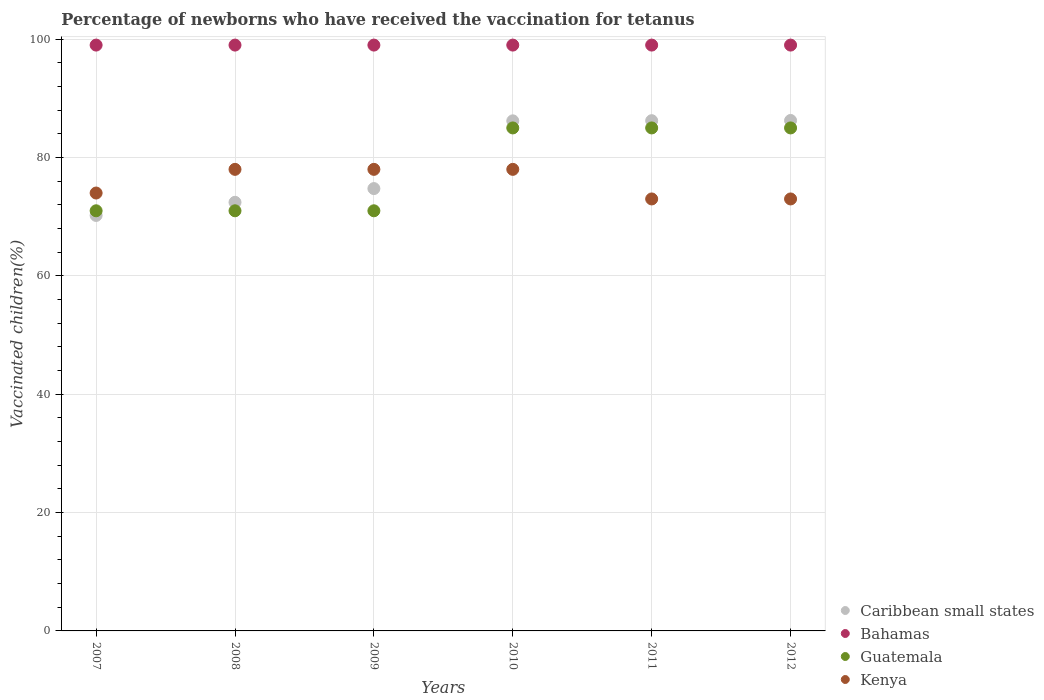How many different coloured dotlines are there?
Provide a short and direct response. 4. What is the percentage of vaccinated children in Caribbean small states in 2011?
Offer a very short reply. 86.23. Across all years, what is the maximum percentage of vaccinated children in Bahamas?
Your answer should be compact. 99. Across all years, what is the minimum percentage of vaccinated children in Kenya?
Make the answer very short. 73. In which year was the percentage of vaccinated children in Guatemala maximum?
Provide a succinct answer. 2010. In which year was the percentage of vaccinated children in Caribbean small states minimum?
Give a very brief answer. 2007. What is the total percentage of vaccinated children in Guatemala in the graph?
Provide a succinct answer. 468. What is the difference between the percentage of vaccinated children in Bahamas in 2011 and the percentage of vaccinated children in Caribbean small states in 2012?
Offer a terse response. 12.74. What is the average percentage of vaccinated children in Kenya per year?
Your answer should be compact. 75.67. In the year 2007, what is the difference between the percentage of vaccinated children in Caribbean small states and percentage of vaccinated children in Bahamas?
Your answer should be compact. -28.79. What is the ratio of the percentage of vaccinated children in Kenya in 2010 to that in 2012?
Your answer should be compact. 1.07. Is the difference between the percentage of vaccinated children in Caribbean small states in 2009 and 2010 greater than the difference between the percentage of vaccinated children in Bahamas in 2009 and 2010?
Your response must be concise. No. What is the difference between the highest and the lowest percentage of vaccinated children in Bahamas?
Offer a terse response. 0. In how many years, is the percentage of vaccinated children in Caribbean small states greater than the average percentage of vaccinated children in Caribbean small states taken over all years?
Ensure brevity in your answer.  3. Is the sum of the percentage of vaccinated children in Guatemala in 2009 and 2012 greater than the maximum percentage of vaccinated children in Bahamas across all years?
Ensure brevity in your answer.  Yes. Is it the case that in every year, the sum of the percentage of vaccinated children in Caribbean small states and percentage of vaccinated children in Kenya  is greater than the sum of percentage of vaccinated children in Guatemala and percentage of vaccinated children in Bahamas?
Provide a succinct answer. No. Is the percentage of vaccinated children in Bahamas strictly less than the percentage of vaccinated children in Kenya over the years?
Your answer should be compact. No. What is the difference between two consecutive major ticks on the Y-axis?
Offer a terse response. 20. Are the values on the major ticks of Y-axis written in scientific E-notation?
Keep it short and to the point. No. Where does the legend appear in the graph?
Offer a very short reply. Bottom right. How are the legend labels stacked?
Your answer should be very brief. Vertical. What is the title of the graph?
Give a very brief answer. Percentage of newborns who have received the vaccination for tetanus. What is the label or title of the X-axis?
Make the answer very short. Years. What is the label or title of the Y-axis?
Your answer should be very brief. Vaccinated children(%). What is the Vaccinated children(%) of Caribbean small states in 2007?
Give a very brief answer. 70.21. What is the Vaccinated children(%) of Bahamas in 2007?
Make the answer very short. 99. What is the Vaccinated children(%) in Guatemala in 2007?
Your response must be concise. 71. What is the Vaccinated children(%) in Caribbean small states in 2008?
Offer a terse response. 72.43. What is the Vaccinated children(%) in Caribbean small states in 2009?
Make the answer very short. 74.75. What is the Vaccinated children(%) in Bahamas in 2009?
Ensure brevity in your answer.  99. What is the Vaccinated children(%) of Caribbean small states in 2010?
Offer a very short reply. 86.2. What is the Vaccinated children(%) in Bahamas in 2010?
Keep it short and to the point. 99. What is the Vaccinated children(%) of Kenya in 2010?
Provide a succinct answer. 78. What is the Vaccinated children(%) in Caribbean small states in 2011?
Your answer should be compact. 86.23. What is the Vaccinated children(%) in Bahamas in 2011?
Make the answer very short. 99. What is the Vaccinated children(%) of Guatemala in 2011?
Keep it short and to the point. 85. What is the Vaccinated children(%) in Caribbean small states in 2012?
Keep it short and to the point. 86.26. What is the Vaccinated children(%) in Kenya in 2012?
Provide a short and direct response. 73. Across all years, what is the maximum Vaccinated children(%) of Caribbean small states?
Make the answer very short. 86.26. Across all years, what is the maximum Vaccinated children(%) in Guatemala?
Ensure brevity in your answer.  85. Across all years, what is the maximum Vaccinated children(%) in Kenya?
Your answer should be very brief. 78. Across all years, what is the minimum Vaccinated children(%) in Caribbean small states?
Provide a short and direct response. 70.21. What is the total Vaccinated children(%) of Caribbean small states in the graph?
Your answer should be compact. 476.08. What is the total Vaccinated children(%) of Bahamas in the graph?
Make the answer very short. 594. What is the total Vaccinated children(%) of Guatemala in the graph?
Give a very brief answer. 468. What is the total Vaccinated children(%) in Kenya in the graph?
Ensure brevity in your answer.  454. What is the difference between the Vaccinated children(%) in Caribbean small states in 2007 and that in 2008?
Make the answer very short. -2.22. What is the difference between the Vaccinated children(%) of Bahamas in 2007 and that in 2008?
Provide a succinct answer. 0. What is the difference between the Vaccinated children(%) in Caribbean small states in 2007 and that in 2009?
Ensure brevity in your answer.  -4.54. What is the difference between the Vaccinated children(%) of Guatemala in 2007 and that in 2009?
Your answer should be compact. 0. What is the difference between the Vaccinated children(%) in Kenya in 2007 and that in 2009?
Offer a terse response. -4. What is the difference between the Vaccinated children(%) in Caribbean small states in 2007 and that in 2010?
Ensure brevity in your answer.  -15.99. What is the difference between the Vaccinated children(%) of Bahamas in 2007 and that in 2010?
Give a very brief answer. 0. What is the difference between the Vaccinated children(%) of Kenya in 2007 and that in 2010?
Keep it short and to the point. -4. What is the difference between the Vaccinated children(%) of Caribbean small states in 2007 and that in 2011?
Your answer should be very brief. -16.01. What is the difference between the Vaccinated children(%) of Caribbean small states in 2007 and that in 2012?
Your answer should be compact. -16.05. What is the difference between the Vaccinated children(%) of Bahamas in 2007 and that in 2012?
Your answer should be compact. 0. What is the difference between the Vaccinated children(%) in Guatemala in 2007 and that in 2012?
Your response must be concise. -14. What is the difference between the Vaccinated children(%) of Kenya in 2007 and that in 2012?
Make the answer very short. 1. What is the difference between the Vaccinated children(%) in Caribbean small states in 2008 and that in 2009?
Keep it short and to the point. -2.32. What is the difference between the Vaccinated children(%) in Bahamas in 2008 and that in 2009?
Ensure brevity in your answer.  0. What is the difference between the Vaccinated children(%) of Guatemala in 2008 and that in 2009?
Provide a short and direct response. 0. What is the difference between the Vaccinated children(%) in Kenya in 2008 and that in 2009?
Offer a terse response. 0. What is the difference between the Vaccinated children(%) in Caribbean small states in 2008 and that in 2010?
Ensure brevity in your answer.  -13.77. What is the difference between the Vaccinated children(%) of Guatemala in 2008 and that in 2010?
Offer a very short reply. -14. What is the difference between the Vaccinated children(%) in Kenya in 2008 and that in 2010?
Provide a short and direct response. 0. What is the difference between the Vaccinated children(%) of Caribbean small states in 2008 and that in 2011?
Your response must be concise. -13.79. What is the difference between the Vaccinated children(%) in Bahamas in 2008 and that in 2011?
Make the answer very short. 0. What is the difference between the Vaccinated children(%) in Guatemala in 2008 and that in 2011?
Keep it short and to the point. -14. What is the difference between the Vaccinated children(%) of Caribbean small states in 2008 and that in 2012?
Offer a very short reply. -13.83. What is the difference between the Vaccinated children(%) of Bahamas in 2008 and that in 2012?
Provide a succinct answer. 0. What is the difference between the Vaccinated children(%) of Kenya in 2008 and that in 2012?
Offer a very short reply. 5. What is the difference between the Vaccinated children(%) in Caribbean small states in 2009 and that in 2010?
Give a very brief answer. -11.45. What is the difference between the Vaccinated children(%) in Bahamas in 2009 and that in 2010?
Your response must be concise. 0. What is the difference between the Vaccinated children(%) in Guatemala in 2009 and that in 2010?
Ensure brevity in your answer.  -14. What is the difference between the Vaccinated children(%) in Kenya in 2009 and that in 2010?
Offer a very short reply. 0. What is the difference between the Vaccinated children(%) in Caribbean small states in 2009 and that in 2011?
Offer a very short reply. -11.47. What is the difference between the Vaccinated children(%) of Bahamas in 2009 and that in 2011?
Your response must be concise. 0. What is the difference between the Vaccinated children(%) in Guatemala in 2009 and that in 2011?
Offer a very short reply. -14. What is the difference between the Vaccinated children(%) of Caribbean small states in 2009 and that in 2012?
Provide a succinct answer. -11.51. What is the difference between the Vaccinated children(%) of Guatemala in 2009 and that in 2012?
Your answer should be very brief. -14. What is the difference between the Vaccinated children(%) in Kenya in 2009 and that in 2012?
Your answer should be very brief. 5. What is the difference between the Vaccinated children(%) of Caribbean small states in 2010 and that in 2011?
Make the answer very short. -0.03. What is the difference between the Vaccinated children(%) of Bahamas in 2010 and that in 2011?
Your response must be concise. 0. What is the difference between the Vaccinated children(%) in Guatemala in 2010 and that in 2011?
Your answer should be compact. 0. What is the difference between the Vaccinated children(%) in Caribbean small states in 2010 and that in 2012?
Ensure brevity in your answer.  -0.06. What is the difference between the Vaccinated children(%) in Guatemala in 2010 and that in 2012?
Your answer should be compact. 0. What is the difference between the Vaccinated children(%) of Kenya in 2010 and that in 2012?
Offer a very short reply. 5. What is the difference between the Vaccinated children(%) in Caribbean small states in 2011 and that in 2012?
Offer a very short reply. -0.03. What is the difference between the Vaccinated children(%) of Bahamas in 2011 and that in 2012?
Your answer should be very brief. 0. What is the difference between the Vaccinated children(%) of Guatemala in 2011 and that in 2012?
Keep it short and to the point. 0. What is the difference between the Vaccinated children(%) of Caribbean small states in 2007 and the Vaccinated children(%) of Bahamas in 2008?
Your response must be concise. -28.79. What is the difference between the Vaccinated children(%) in Caribbean small states in 2007 and the Vaccinated children(%) in Guatemala in 2008?
Offer a very short reply. -0.79. What is the difference between the Vaccinated children(%) of Caribbean small states in 2007 and the Vaccinated children(%) of Kenya in 2008?
Keep it short and to the point. -7.79. What is the difference between the Vaccinated children(%) of Bahamas in 2007 and the Vaccinated children(%) of Guatemala in 2008?
Your answer should be very brief. 28. What is the difference between the Vaccinated children(%) of Guatemala in 2007 and the Vaccinated children(%) of Kenya in 2008?
Give a very brief answer. -7. What is the difference between the Vaccinated children(%) of Caribbean small states in 2007 and the Vaccinated children(%) of Bahamas in 2009?
Provide a succinct answer. -28.79. What is the difference between the Vaccinated children(%) of Caribbean small states in 2007 and the Vaccinated children(%) of Guatemala in 2009?
Offer a terse response. -0.79. What is the difference between the Vaccinated children(%) in Caribbean small states in 2007 and the Vaccinated children(%) in Kenya in 2009?
Provide a short and direct response. -7.79. What is the difference between the Vaccinated children(%) of Bahamas in 2007 and the Vaccinated children(%) of Kenya in 2009?
Your answer should be very brief. 21. What is the difference between the Vaccinated children(%) in Caribbean small states in 2007 and the Vaccinated children(%) in Bahamas in 2010?
Offer a very short reply. -28.79. What is the difference between the Vaccinated children(%) in Caribbean small states in 2007 and the Vaccinated children(%) in Guatemala in 2010?
Your answer should be compact. -14.79. What is the difference between the Vaccinated children(%) of Caribbean small states in 2007 and the Vaccinated children(%) of Kenya in 2010?
Make the answer very short. -7.79. What is the difference between the Vaccinated children(%) in Bahamas in 2007 and the Vaccinated children(%) in Guatemala in 2010?
Make the answer very short. 14. What is the difference between the Vaccinated children(%) of Caribbean small states in 2007 and the Vaccinated children(%) of Bahamas in 2011?
Provide a succinct answer. -28.79. What is the difference between the Vaccinated children(%) of Caribbean small states in 2007 and the Vaccinated children(%) of Guatemala in 2011?
Give a very brief answer. -14.79. What is the difference between the Vaccinated children(%) in Caribbean small states in 2007 and the Vaccinated children(%) in Kenya in 2011?
Provide a short and direct response. -2.79. What is the difference between the Vaccinated children(%) in Bahamas in 2007 and the Vaccinated children(%) in Kenya in 2011?
Keep it short and to the point. 26. What is the difference between the Vaccinated children(%) of Caribbean small states in 2007 and the Vaccinated children(%) of Bahamas in 2012?
Ensure brevity in your answer.  -28.79. What is the difference between the Vaccinated children(%) of Caribbean small states in 2007 and the Vaccinated children(%) of Guatemala in 2012?
Offer a very short reply. -14.79. What is the difference between the Vaccinated children(%) of Caribbean small states in 2007 and the Vaccinated children(%) of Kenya in 2012?
Make the answer very short. -2.79. What is the difference between the Vaccinated children(%) of Bahamas in 2007 and the Vaccinated children(%) of Guatemala in 2012?
Offer a very short reply. 14. What is the difference between the Vaccinated children(%) in Bahamas in 2007 and the Vaccinated children(%) in Kenya in 2012?
Offer a very short reply. 26. What is the difference between the Vaccinated children(%) in Caribbean small states in 2008 and the Vaccinated children(%) in Bahamas in 2009?
Your response must be concise. -26.57. What is the difference between the Vaccinated children(%) in Caribbean small states in 2008 and the Vaccinated children(%) in Guatemala in 2009?
Your response must be concise. 1.43. What is the difference between the Vaccinated children(%) of Caribbean small states in 2008 and the Vaccinated children(%) of Kenya in 2009?
Provide a short and direct response. -5.57. What is the difference between the Vaccinated children(%) of Guatemala in 2008 and the Vaccinated children(%) of Kenya in 2009?
Provide a succinct answer. -7. What is the difference between the Vaccinated children(%) of Caribbean small states in 2008 and the Vaccinated children(%) of Bahamas in 2010?
Keep it short and to the point. -26.57. What is the difference between the Vaccinated children(%) of Caribbean small states in 2008 and the Vaccinated children(%) of Guatemala in 2010?
Offer a terse response. -12.57. What is the difference between the Vaccinated children(%) of Caribbean small states in 2008 and the Vaccinated children(%) of Kenya in 2010?
Your answer should be compact. -5.57. What is the difference between the Vaccinated children(%) of Bahamas in 2008 and the Vaccinated children(%) of Guatemala in 2010?
Provide a short and direct response. 14. What is the difference between the Vaccinated children(%) in Bahamas in 2008 and the Vaccinated children(%) in Kenya in 2010?
Make the answer very short. 21. What is the difference between the Vaccinated children(%) of Caribbean small states in 2008 and the Vaccinated children(%) of Bahamas in 2011?
Keep it short and to the point. -26.57. What is the difference between the Vaccinated children(%) of Caribbean small states in 2008 and the Vaccinated children(%) of Guatemala in 2011?
Offer a very short reply. -12.57. What is the difference between the Vaccinated children(%) of Caribbean small states in 2008 and the Vaccinated children(%) of Kenya in 2011?
Provide a succinct answer. -0.57. What is the difference between the Vaccinated children(%) in Guatemala in 2008 and the Vaccinated children(%) in Kenya in 2011?
Ensure brevity in your answer.  -2. What is the difference between the Vaccinated children(%) in Caribbean small states in 2008 and the Vaccinated children(%) in Bahamas in 2012?
Provide a succinct answer. -26.57. What is the difference between the Vaccinated children(%) in Caribbean small states in 2008 and the Vaccinated children(%) in Guatemala in 2012?
Provide a succinct answer. -12.57. What is the difference between the Vaccinated children(%) of Caribbean small states in 2008 and the Vaccinated children(%) of Kenya in 2012?
Provide a succinct answer. -0.57. What is the difference between the Vaccinated children(%) of Bahamas in 2008 and the Vaccinated children(%) of Guatemala in 2012?
Keep it short and to the point. 14. What is the difference between the Vaccinated children(%) in Bahamas in 2008 and the Vaccinated children(%) in Kenya in 2012?
Your response must be concise. 26. What is the difference between the Vaccinated children(%) of Guatemala in 2008 and the Vaccinated children(%) of Kenya in 2012?
Provide a succinct answer. -2. What is the difference between the Vaccinated children(%) of Caribbean small states in 2009 and the Vaccinated children(%) of Bahamas in 2010?
Offer a very short reply. -24.25. What is the difference between the Vaccinated children(%) in Caribbean small states in 2009 and the Vaccinated children(%) in Guatemala in 2010?
Offer a terse response. -10.25. What is the difference between the Vaccinated children(%) of Caribbean small states in 2009 and the Vaccinated children(%) of Kenya in 2010?
Offer a terse response. -3.25. What is the difference between the Vaccinated children(%) in Bahamas in 2009 and the Vaccinated children(%) in Guatemala in 2010?
Provide a short and direct response. 14. What is the difference between the Vaccinated children(%) in Caribbean small states in 2009 and the Vaccinated children(%) in Bahamas in 2011?
Keep it short and to the point. -24.25. What is the difference between the Vaccinated children(%) of Caribbean small states in 2009 and the Vaccinated children(%) of Guatemala in 2011?
Offer a very short reply. -10.25. What is the difference between the Vaccinated children(%) in Caribbean small states in 2009 and the Vaccinated children(%) in Kenya in 2011?
Offer a very short reply. 1.75. What is the difference between the Vaccinated children(%) in Caribbean small states in 2009 and the Vaccinated children(%) in Bahamas in 2012?
Your response must be concise. -24.25. What is the difference between the Vaccinated children(%) in Caribbean small states in 2009 and the Vaccinated children(%) in Guatemala in 2012?
Your answer should be very brief. -10.25. What is the difference between the Vaccinated children(%) of Caribbean small states in 2009 and the Vaccinated children(%) of Kenya in 2012?
Provide a short and direct response. 1.75. What is the difference between the Vaccinated children(%) in Bahamas in 2009 and the Vaccinated children(%) in Guatemala in 2012?
Make the answer very short. 14. What is the difference between the Vaccinated children(%) of Bahamas in 2009 and the Vaccinated children(%) of Kenya in 2012?
Offer a terse response. 26. What is the difference between the Vaccinated children(%) in Caribbean small states in 2010 and the Vaccinated children(%) in Bahamas in 2011?
Your response must be concise. -12.8. What is the difference between the Vaccinated children(%) of Caribbean small states in 2010 and the Vaccinated children(%) of Guatemala in 2011?
Offer a terse response. 1.2. What is the difference between the Vaccinated children(%) of Caribbean small states in 2010 and the Vaccinated children(%) of Kenya in 2011?
Keep it short and to the point. 13.2. What is the difference between the Vaccinated children(%) in Bahamas in 2010 and the Vaccinated children(%) in Kenya in 2011?
Offer a terse response. 26. What is the difference between the Vaccinated children(%) of Caribbean small states in 2010 and the Vaccinated children(%) of Bahamas in 2012?
Provide a succinct answer. -12.8. What is the difference between the Vaccinated children(%) in Caribbean small states in 2010 and the Vaccinated children(%) in Guatemala in 2012?
Your answer should be very brief. 1.2. What is the difference between the Vaccinated children(%) in Caribbean small states in 2010 and the Vaccinated children(%) in Kenya in 2012?
Your answer should be very brief. 13.2. What is the difference between the Vaccinated children(%) in Bahamas in 2010 and the Vaccinated children(%) in Guatemala in 2012?
Your answer should be very brief. 14. What is the difference between the Vaccinated children(%) in Caribbean small states in 2011 and the Vaccinated children(%) in Bahamas in 2012?
Your answer should be compact. -12.77. What is the difference between the Vaccinated children(%) of Caribbean small states in 2011 and the Vaccinated children(%) of Guatemala in 2012?
Your answer should be compact. 1.23. What is the difference between the Vaccinated children(%) in Caribbean small states in 2011 and the Vaccinated children(%) in Kenya in 2012?
Offer a terse response. 13.23. What is the difference between the Vaccinated children(%) of Bahamas in 2011 and the Vaccinated children(%) of Guatemala in 2012?
Your answer should be very brief. 14. What is the difference between the Vaccinated children(%) in Bahamas in 2011 and the Vaccinated children(%) in Kenya in 2012?
Offer a very short reply. 26. What is the difference between the Vaccinated children(%) in Guatemala in 2011 and the Vaccinated children(%) in Kenya in 2012?
Give a very brief answer. 12. What is the average Vaccinated children(%) in Caribbean small states per year?
Your answer should be compact. 79.35. What is the average Vaccinated children(%) in Kenya per year?
Ensure brevity in your answer.  75.67. In the year 2007, what is the difference between the Vaccinated children(%) in Caribbean small states and Vaccinated children(%) in Bahamas?
Provide a short and direct response. -28.79. In the year 2007, what is the difference between the Vaccinated children(%) in Caribbean small states and Vaccinated children(%) in Guatemala?
Offer a terse response. -0.79. In the year 2007, what is the difference between the Vaccinated children(%) of Caribbean small states and Vaccinated children(%) of Kenya?
Make the answer very short. -3.79. In the year 2007, what is the difference between the Vaccinated children(%) of Bahamas and Vaccinated children(%) of Guatemala?
Keep it short and to the point. 28. In the year 2007, what is the difference between the Vaccinated children(%) of Guatemala and Vaccinated children(%) of Kenya?
Your response must be concise. -3. In the year 2008, what is the difference between the Vaccinated children(%) in Caribbean small states and Vaccinated children(%) in Bahamas?
Provide a short and direct response. -26.57. In the year 2008, what is the difference between the Vaccinated children(%) in Caribbean small states and Vaccinated children(%) in Guatemala?
Your answer should be compact. 1.43. In the year 2008, what is the difference between the Vaccinated children(%) in Caribbean small states and Vaccinated children(%) in Kenya?
Keep it short and to the point. -5.57. In the year 2008, what is the difference between the Vaccinated children(%) of Guatemala and Vaccinated children(%) of Kenya?
Offer a very short reply. -7. In the year 2009, what is the difference between the Vaccinated children(%) of Caribbean small states and Vaccinated children(%) of Bahamas?
Offer a very short reply. -24.25. In the year 2009, what is the difference between the Vaccinated children(%) of Caribbean small states and Vaccinated children(%) of Guatemala?
Keep it short and to the point. 3.75. In the year 2009, what is the difference between the Vaccinated children(%) of Caribbean small states and Vaccinated children(%) of Kenya?
Offer a terse response. -3.25. In the year 2009, what is the difference between the Vaccinated children(%) of Bahamas and Vaccinated children(%) of Guatemala?
Provide a succinct answer. 28. In the year 2009, what is the difference between the Vaccinated children(%) in Bahamas and Vaccinated children(%) in Kenya?
Your response must be concise. 21. In the year 2009, what is the difference between the Vaccinated children(%) of Guatemala and Vaccinated children(%) of Kenya?
Your answer should be compact. -7. In the year 2010, what is the difference between the Vaccinated children(%) in Caribbean small states and Vaccinated children(%) in Bahamas?
Keep it short and to the point. -12.8. In the year 2010, what is the difference between the Vaccinated children(%) of Caribbean small states and Vaccinated children(%) of Guatemala?
Offer a very short reply. 1.2. In the year 2010, what is the difference between the Vaccinated children(%) in Caribbean small states and Vaccinated children(%) in Kenya?
Keep it short and to the point. 8.2. In the year 2010, what is the difference between the Vaccinated children(%) in Bahamas and Vaccinated children(%) in Guatemala?
Make the answer very short. 14. In the year 2010, what is the difference between the Vaccinated children(%) of Bahamas and Vaccinated children(%) of Kenya?
Provide a short and direct response. 21. In the year 2011, what is the difference between the Vaccinated children(%) in Caribbean small states and Vaccinated children(%) in Bahamas?
Provide a succinct answer. -12.77. In the year 2011, what is the difference between the Vaccinated children(%) in Caribbean small states and Vaccinated children(%) in Guatemala?
Provide a short and direct response. 1.23. In the year 2011, what is the difference between the Vaccinated children(%) in Caribbean small states and Vaccinated children(%) in Kenya?
Provide a succinct answer. 13.23. In the year 2011, what is the difference between the Vaccinated children(%) in Bahamas and Vaccinated children(%) in Kenya?
Provide a short and direct response. 26. In the year 2012, what is the difference between the Vaccinated children(%) in Caribbean small states and Vaccinated children(%) in Bahamas?
Your answer should be compact. -12.74. In the year 2012, what is the difference between the Vaccinated children(%) of Caribbean small states and Vaccinated children(%) of Guatemala?
Your answer should be compact. 1.26. In the year 2012, what is the difference between the Vaccinated children(%) of Caribbean small states and Vaccinated children(%) of Kenya?
Ensure brevity in your answer.  13.26. In the year 2012, what is the difference between the Vaccinated children(%) of Bahamas and Vaccinated children(%) of Kenya?
Keep it short and to the point. 26. In the year 2012, what is the difference between the Vaccinated children(%) of Guatemala and Vaccinated children(%) of Kenya?
Offer a terse response. 12. What is the ratio of the Vaccinated children(%) in Caribbean small states in 2007 to that in 2008?
Your response must be concise. 0.97. What is the ratio of the Vaccinated children(%) of Guatemala in 2007 to that in 2008?
Your answer should be compact. 1. What is the ratio of the Vaccinated children(%) of Kenya in 2007 to that in 2008?
Ensure brevity in your answer.  0.95. What is the ratio of the Vaccinated children(%) of Caribbean small states in 2007 to that in 2009?
Provide a short and direct response. 0.94. What is the ratio of the Vaccinated children(%) in Kenya in 2007 to that in 2009?
Provide a succinct answer. 0.95. What is the ratio of the Vaccinated children(%) in Caribbean small states in 2007 to that in 2010?
Make the answer very short. 0.81. What is the ratio of the Vaccinated children(%) in Guatemala in 2007 to that in 2010?
Provide a succinct answer. 0.84. What is the ratio of the Vaccinated children(%) in Kenya in 2007 to that in 2010?
Give a very brief answer. 0.95. What is the ratio of the Vaccinated children(%) of Caribbean small states in 2007 to that in 2011?
Your answer should be compact. 0.81. What is the ratio of the Vaccinated children(%) of Guatemala in 2007 to that in 2011?
Provide a short and direct response. 0.84. What is the ratio of the Vaccinated children(%) in Kenya in 2007 to that in 2011?
Make the answer very short. 1.01. What is the ratio of the Vaccinated children(%) of Caribbean small states in 2007 to that in 2012?
Offer a terse response. 0.81. What is the ratio of the Vaccinated children(%) in Guatemala in 2007 to that in 2012?
Your answer should be compact. 0.84. What is the ratio of the Vaccinated children(%) in Kenya in 2007 to that in 2012?
Ensure brevity in your answer.  1.01. What is the ratio of the Vaccinated children(%) in Caribbean small states in 2008 to that in 2009?
Keep it short and to the point. 0.97. What is the ratio of the Vaccinated children(%) of Guatemala in 2008 to that in 2009?
Your answer should be very brief. 1. What is the ratio of the Vaccinated children(%) of Caribbean small states in 2008 to that in 2010?
Ensure brevity in your answer.  0.84. What is the ratio of the Vaccinated children(%) of Bahamas in 2008 to that in 2010?
Offer a terse response. 1. What is the ratio of the Vaccinated children(%) in Guatemala in 2008 to that in 2010?
Offer a terse response. 0.84. What is the ratio of the Vaccinated children(%) of Kenya in 2008 to that in 2010?
Give a very brief answer. 1. What is the ratio of the Vaccinated children(%) in Caribbean small states in 2008 to that in 2011?
Offer a terse response. 0.84. What is the ratio of the Vaccinated children(%) of Guatemala in 2008 to that in 2011?
Make the answer very short. 0.84. What is the ratio of the Vaccinated children(%) of Kenya in 2008 to that in 2011?
Offer a very short reply. 1.07. What is the ratio of the Vaccinated children(%) of Caribbean small states in 2008 to that in 2012?
Offer a very short reply. 0.84. What is the ratio of the Vaccinated children(%) of Guatemala in 2008 to that in 2012?
Your response must be concise. 0.84. What is the ratio of the Vaccinated children(%) of Kenya in 2008 to that in 2012?
Your response must be concise. 1.07. What is the ratio of the Vaccinated children(%) in Caribbean small states in 2009 to that in 2010?
Your answer should be compact. 0.87. What is the ratio of the Vaccinated children(%) of Guatemala in 2009 to that in 2010?
Offer a very short reply. 0.84. What is the ratio of the Vaccinated children(%) in Kenya in 2009 to that in 2010?
Your response must be concise. 1. What is the ratio of the Vaccinated children(%) in Caribbean small states in 2009 to that in 2011?
Your response must be concise. 0.87. What is the ratio of the Vaccinated children(%) of Guatemala in 2009 to that in 2011?
Provide a succinct answer. 0.84. What is the ratio of the Vaccinated children(%) in Kenya in 2009 to that in 2011?
Offer a very short reply. 1.07. What is the ratio of the Vaccinated children(%) of Caribbean small states in 2009 to that in 2012?
Make the answer very short. 0.87. What is the ratio of the Vaccinated children(%) in Bahamas in 2009 to that in 2012?
Your response must be concise. 1. What is the ratio of the Vaccinated children(%) of Guatemala in 2009 to that in 2012?
Offer a very short reply. 0.84. What is the ratio of the Vaccinated children(%) of Kenya in 2009 to that in 2012?
Ensure brevity in your answer.  1.07. What is the ratio of the Vaccinated children(%) of Bahamas in 2010 to that in 2011?
Your answer should be very brief. 1. What is the ratio of the Vaccinated children(%) of Guatemala in 2010 to that in 2011?
Provide a succinct answer. 1. What is the ratio of the Vaccinated children(%) in Kenya in 2010 to that in 2011?
Your response must be concise. 1.07. What is the ratio of the Vaccinated children(%) in Caribbean small states in 2010 to that in 2012?
Give a very brief answer. 1. What is the ratio of the Vaccinated children(%) of Guatemala in 2010 to that in 2012?
Give a very brief answer. 1. What is the ratio of the Vaccinated children(%) in Kenya in 2010 to that in 2012?
Your answer should be very brief. 1.07. What is the ratio of the Vaccinated children(%) of Bahamas in 2011 to that in 2012?
Offer a terse response. 1. What is the ratio of the Vaccinated children(%) of Guatemala in 2011 to that in 2012?
Ensure brevity in your answer.  1. What is the ratio of the Vaccinated children(%) of Kenya in 2011 to that in 2012?
Your answer should be very brief. 1. What is the difference between the highest and the second highest Vaccinated children(%) of Caribbean small states?
Ensure brevity in your answer.  0.03. What is the difference between the highest and the second highest Vaccinated children(%) of Guatemala?
Ensure brevity in your answer.  0. What is the difference between the highest and the lowest Vaccinated children(%) of Caribbean small states?
Ensure brevity in your answer.  16.05. What is the difference between the highest and the lowest Vaccinated children(%) of Bahamas?
Keep it short and to the point. 0. What is the difference between the highest and the lowest Vaccinated children(%) of Kenya?
Provide a succinct answer. 5. 